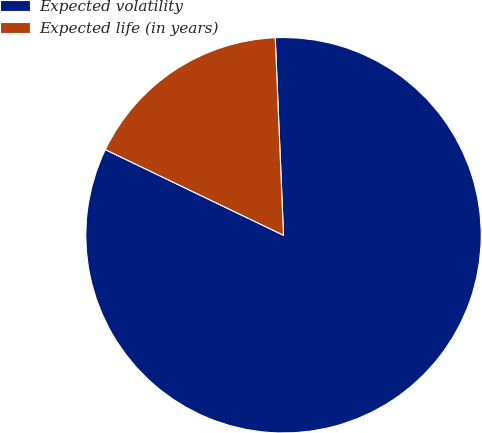<chart> <loc_0><loc_0><loc_500><loc_500><pie_chart><fcel>Expected volatility<fcel>Expected life (in years)<nl><fcel>82.8%<fcel>17.2%<nl></chart> 